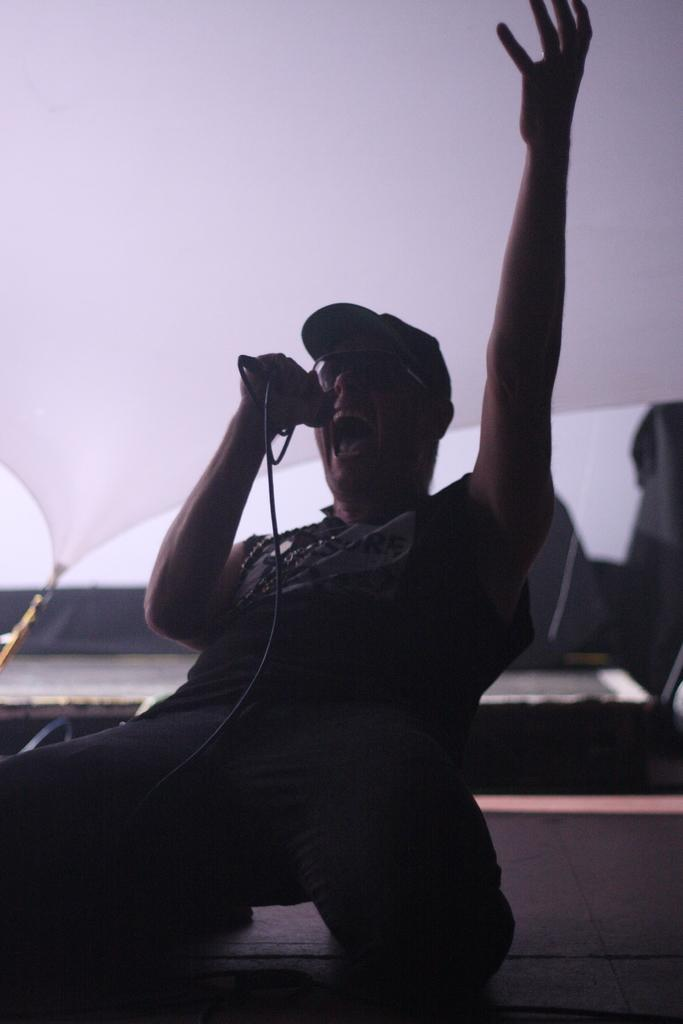What is the person in the image doing? The person is singing. What is the person holding in the image? The person is holding a microphone and a wire. What accessories is the person wearing? The person is wearing a cap and goggles. What can be seen in the background of the image? There are objects and cloth visible in the background. Where is the lunchroom located in the image? There is no lunchroom present in the image. Can you see a stream in the background of the image? There is no stream visible in the background of the image. 